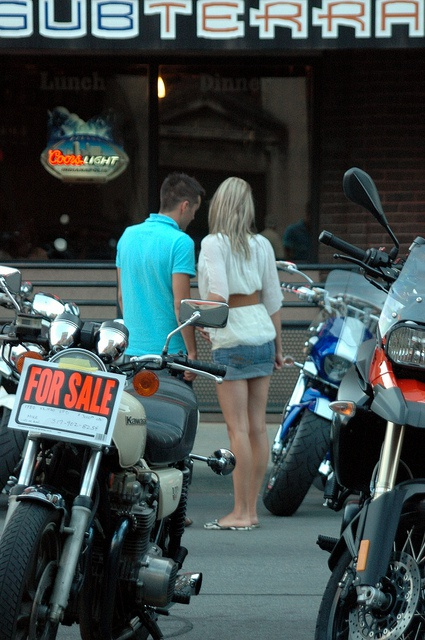Describe the objects in this image and their specific colors. I can see motorcycle in lightblue, black, gray, and purple tones, motorcycle in lightblue, black, gray, and purple tones, people in lightblue, gray, and darkgray tones, motorcycle in lightblue, black, gray, and blue tones, and people in lightblue, cyan, and black tones in this image. 